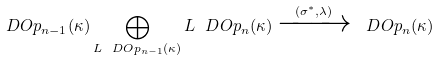Convert formula to latex. <formula><loc_0><loc_0><loc_500><loc_500>\ D O p _ { n - 1 } ( \kappa ) \bigoplus _ { L \ D O p _ { n - 1 } ( \kappa ) } L \ D O p _ { n } ( \kappa ) \xrightarrow { ( \sigma ^ { * } , \lambda ) } \ D O p _ { n } ( \kappa )</formula> 